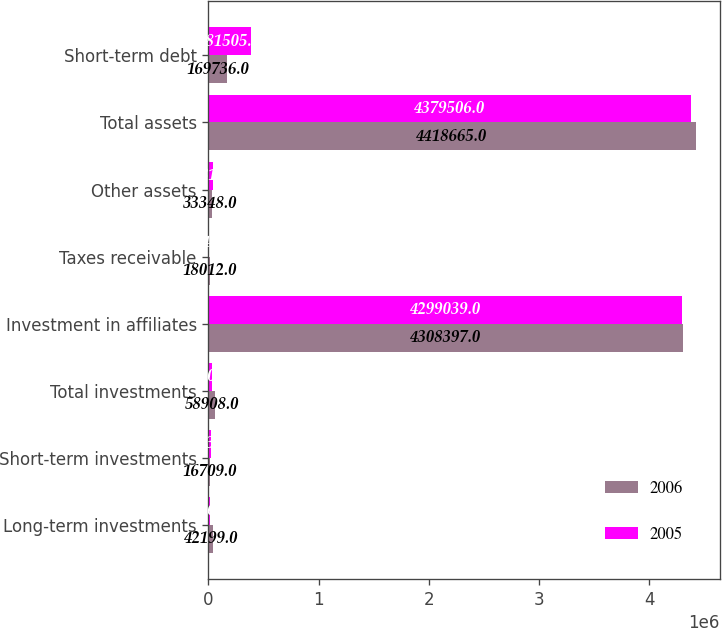<chart> <loc_0><loc_0><loc_500><loc_500><stacked_bar_chart><ecel><fcel>Long-term investments<fcel>Short-term investments<fcel>Total investments<fcel>Investment in affiliates<fcel>Taxes receivable<fcel>Other assets<fcel>Total assets<fcel>Short-term debt<nl><fcel>2006<fcel>42199<fcel>16709<fcel>58908<fcel>4.3084e+06<fcel>18012<fcel>33348<fcel>4.41866e+06<fcel>169736<nl><fcel>2005<fcel>10365<fcel>21035<fcel>31400<fcel>4.29904e+06<fcel>5248<fcel>43819<fcel>4.37951e+06<fcel>381505<nl></chart> 